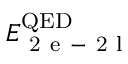Convert formula to latex. <formula><loc_0><loc_0><loc_500><loc_500>E _ { 2 e - 2 l } ^ { Q E D }</formula> 